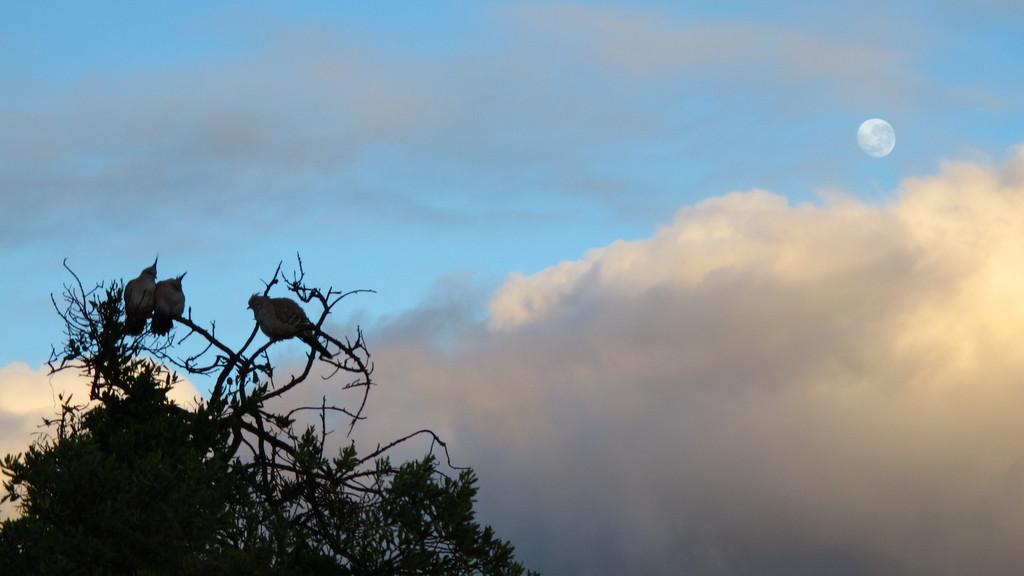What is located on the left side of the image? There is a tree on the left side of the image. Where is the tree positioned in the image? The tree is located at the bottom of the image. How many birds are on the tree? There are three birds on the tree. What is visible at the top of the image? The sky is visible at the top of the image, and there are clouds in the sky. What is located on the right side of the image? There is a moon on the right side of the image. Where is the moon positioned in the image? The moon is located at the top of the image. What type of songs are the birds singing in the image? There is no indication in the image that the birds are singing songs. What type of pot is located at the bottom of the image? There is no pot present in the image; it features a tree on the left side. How many soldiers are visible in the image? There are no soldiers or army depicted in the image. 